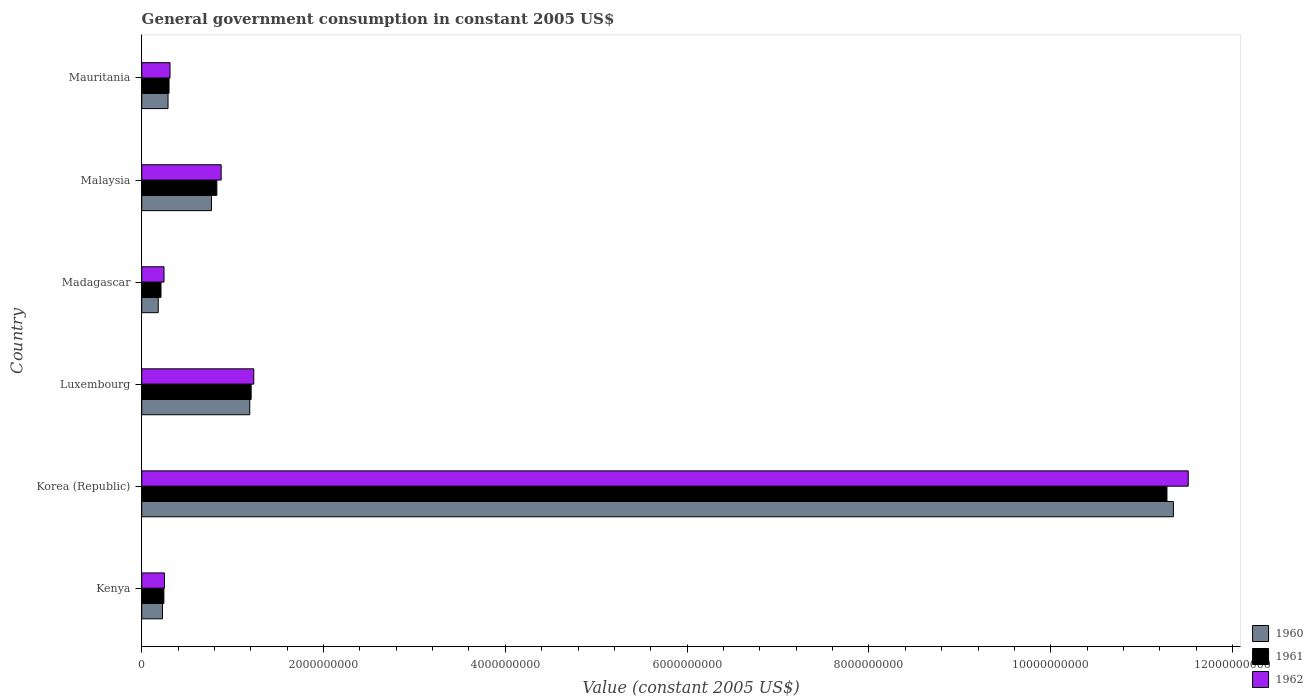In how many cases, is the number of bars for a given country not equal to the number of legend labels?
Give a very brief answer. 0. What is the government conusmption in 1961 in Korea (Republic)?
Your answer should be compact. 1.13e+1. Across all countries, what is the maximum government conusmption in 1961?
Your answer should be very brief. 1.13e+1. Across all countries, what is the minimum government conusmption in 1962?
Your answer should be very brief. 2.45e+08. In which country was the government conusmption in 1960 maximum?
Provide a succinct answer. Korea (Republic). In which country was the government conusmption in 1961 minimum?
Provide a short and direct response. Madagascar. What is the total government conusmption in 1960 in the graph?
Your response must be concise. 1.40e+1. What is the difference between the government conusmption in 1960 in Korea (Republic) and that in Mauritania?
Your response must be concise. 1.11e+1. What is the difference between the government conusmption in 1962 in Luxembourg and the government conusmption in 1960 in Kenya?
Offer a very short reply. 1.00e+09. What is the average government conusmption in 1961 per country?
Your answer should be compact. 2.34e+09. What is the difference between the government conusmption in 1962 and government conusmption in 1961 in Korea (Republic)?
Keep it short and to the point. 2.34e+08. What is the ratio of the government conusmption in 1960 in Madagascar to that in Malaysia?
Provide a succinct answer. 0.24. Is the government conusmption in 1962 in Kenya less than that in Luxembourg?
Your answer should be compact. Yes. Is the difference between the government conusmption in 1962 in Luxembourg and Madagascar greater than the difference between the government conusmption in 1961 in Luxembourg and Madagascar?
Offer a terse response. No. What is the difference between the highest and the second highest government conusmption in 1960?
Your answer should be compact. 1.02e+1. What is the difference between the highest and the lowest government conusmption in 1962?
Your answer should be very brief. 1.13e+1. What does the 1st bar from the bottom in Madagascar represents?
Keep it short and to the point. 1960. Is it the case that in every country, the sum of the government conusmption in 1962 and government conusmption in 1960 is greater than the government conusmption in 1961?
Give a very brief answer. Yes. Are all the bars in the graph horizontal?
Your response must be concise. Yes. How many countries are there in the graph?
Your answer should be compact. 6. Are the values on the major ticks of X-axis written in scientific E-notation?
Provide a short and direct response. No. Does the graph contain any zero values?
Make the answer very short. No. Does the graph contain grids?
Your response must be concise. No. Where does the legend appear in the graph?
Provide a succinct answer. Bottom right. How many legend labels are there?
Offer a terse response. 3. How are the legend labels stacked?
Make the answer very short. Vertical. What is the title of the graph?
Your response must be concise. General government consumption in constant 2005 US$. Does "2004" appear as one of the legend labels in the graph?
Offer a very short reply. No. What is the label or title of the X-axis?
Your answer should be very brief. Value (constant 2005 US$). What is the Value (constant 2005 US$) of 1960 in Kenya?
Your answer should be very brief. 2.28e+08. What is the Value (constant 2005 US$) in 1961 in Kenya?
Provide a short and direct response. 2.44e+08. What is the Value (constant 2005 US$) in 1962 in Kenya?
Keep it short and to the point. 2.50e+08. What is the Value (constant 2005 US$) in 1960 in Korea (Republic)?
Your answer should be compact. 1.13e+1. What is the Value (constant 2005 US$) of 1961 in Korea (Republic)?
Make the answer very short. 1.13e+1. What is the Value (constant 2005 US$) of 1962 in Korea (Republic)?
Give a very brief answer. 1.15e+1. What is the Value (constant 2005 US$) in 1960 in Luxembourg?
Your answer should be very brief. 1.19e+09. What is the Value (constant 2005 US$) of 1961 in Luxembourg?
Give a very brief answer. 1.20e+09. What is the Value (constant 2005 US$) of 1962 in Luxembourg?
Give a very brief answer. 1.23e+09. What is the Value (constant 2005 US$) in 1960 in Madagascar?
Provide a succinct answer. 1.82e+08. What is the Value (constant 2005 US$) in 1961 in Madagascar?
Provide a short and direct response. 2.12e+08. What is the Value (constant 2005 US$) in 1962 in Madagascar?
Your response must be concise. 2.45e+08. What is the Value (constant 2005 US$) of 1960 in Malaysia?
Offer a terse response. 7.67e+08. What is the Value (constant 2005 US$) in 1961 in Malaysia?
Ensure brevity in your answer.  8.26e+08. What is the Value (constant 2005 US$) in 1962 in Malaysia?
Offer a terse response. 8.74e+08. What is the Value (constant 2005 US$) in 1960 in Mauritania?
Your answer should be compact. 2.89e+08. What is the Value (constant 2005 US$) in 1961 in Mauritania?
Ensure brevity in your answer.  3.00e+08. What is the Value (constant 2005 US$) in 1962 in Mauritania?
Provide a short and direct response. 3.11e+08. Across all countries, what is the maximum Value (constant 2005 US$) of 1960?
Give a very brief answer. 1.13e+1. Across all countries, what is the maximum Value (constant 2005 US$) in 1961?
Ensure brevity in your answer.  1.13e+1. Across all countries, what is the maximum Value (constant 2005 US$) in 1962?
Ensure brevity in your answer.  1.15e+1. Across all countries, what is the minimum Value (constant 2005 US$) of 1960?
Your answer should be very brief. 1.82e+08. Across all countries, what is the minimum Value (constant 2005 US$) of 1961?
Ensure brevity in your answer.  2.12e+08. Across all countries, what is the minimum Value (constant 2005 US$) of 1962?
Your answer should be compact. 2.45e+08. What is the total Value (constant 2005 US$) of 1960 in the graph?
Your response must be concise. 1.40e+1. What is the total Value (constant 2005 US$) in 1961 in the graph?
Ensure brevity in your answer.  1.41e+1. What is the total Value (constant 2005 US$) of 1962 in the graph?
Offer a terse response. 1.44e+1. What is the difference between the Value (constant 2005 US$) of 1960 in Kenya and that in Korea (Republic)?
Your response must be concise. -1.11e+1. What is the difference between the Value (constant 2005 US$) of 1961 in Kenya and that in Korea (Republic)?
Keep it short and to the point. -1.10e+1. What is the difference between the Value (constant 2005 US$) of 1962 in Kenya and that in Korea (Republic)?
Your answer should be compact. -1.13e+1. What is the difference between the Value (constant 2005 US$) of 1960 in Kenya and that in Luxembourg?
Offer a terse response. -9.60e+08. What is the difference between the Value (constant 2005 US$) of 1961 in Kenya and that in Luxembourg?
Offer a very short reply. -9.60e+08. What is the difference between the Value (constant 2005 US$) in 1962 in Kenya and that in Luxembourg?
Offer a very short reply. -9.82e+08. What is the difference between the Value (constant 2005 US$) in 1960 in Kenya and that in Madagascar?
Provide a succinct answer. 4.65e+07. What is the difference between the Value (constant 2005 US$) in 1961 in Kenya and that in Madagascar?
Offer a very short reply. 3.18e+07. What is the difference between the Value (constant 2005 US$) in 1962 in Kenya and that in Madagascar?
Provide a short and direct response. 5.27e+06. What is the difference between the Value (constant 2005 US$) in 1960 in Kenya and that in Malaysia?
Your response must be concise. -5.39e+08. What is the difference between the Value (constant 2005 US$) of 1961 in Kenya and that in Malaysia?
Your answer should be compact. -5.83e+08. What is the difference between the Value (constant 2005 US$) in 1962 in Kenya and that in Malaysia?
Your response must be concise. -6.24e+08. What is the difference between the Value (constant 2005 US$) in 1960 in Kenya and that in Mauritania?
Offer a very short reply. -6.12e+07. What is the difference between the Value (constant 2005 US$) in 1961 in Kenya and that in Mauritania?
Keep it short and to the point. -5.66e+07. What is the difference between the Value (constant 2005 US$) of 1962 in Kenya and that in Mauritania?
Your answer should be compact. -6.09e+07. What is the difference between the Value (constant 2005 US$) of 1960 in Korea (Republic) and that in Luxembourg?
Offer a terse response. 1.02e+1. What is the difference between the Value (constant 2005 US$) in 1961 in Korea (Republic) and that in Luxembourg?
Give a very brief answer. 1.01e+1. What is the difference between the Value (constant 2005 US$) of 1962 in Korea (Republic) and that in Luxembourg?
Provide a succinct answer. 1.03e+1. What is the difference between the Value (constant 2005 US$) in 1960 in Korea (Republic) and that in Madagascar?
Provide a succinct answer. 1.12e+1. What is the difference between the Value (constant 2005 US$) in 1961 in Korea (Republic) and that in Madagascar?
Your response must be concise. 1.11e+1. What is the difference between the Value (constant 2005 US$) of 1962 in Korea (Republic) and that in Madagascar?
Provide a short and direct response. 1.13e+1. What is the difference between the Value (constant 2005 US$) of 1960 in Korea (Republic) and that in Malaysia?
Ensure brevity in your answer.  1.06e+1. What is the difference between the Value (constant 2005 US$) of 1961 in Korea (Republic) and that in Malaysia?
Give a very brief answer. 1.05e+1. What is the difference between the Value (constant 2005 US$) of 1962 in Korea (Republic) and that in Malaysia?
Offer a terse response. 1.06e+1. What is the difference between the Value (constant 2005 US$) in 1960 in Korea (Republic) and that in Mauritania?
Keep it short and to the point. 1.11e+1. What is the difference between the Value (constant 2005 US$) in 1961 in Korea (Republic) and that in Mauritania?
Ensure brevity in your answer.  1.10e+1. What is the difference between the Value (constant 2005 US$) in 1962 in Korea (Republic) and that in Mauritania?
Your answer should be very brief. 1.12e+1. What is the difference between the Value (constant 2005 US$) in 1960 in Luxembourg and that in Madagascar?
Keep it short and to the point. 1.01e+09. What is the difference between the Value (constant 2005 US$) of 1961 in Luxembourg and that in Madagascar?
Ensure brevity in your answer.  9.92e+08. What is the difference between the Value (constant 2005 US$) in 1962 in Luxembourg and that in Madagascar?
Ensure brevity in your answer.  9.87e+08. What is the difference between the Value (constant 2005 US$) in 1960 in Luxembourg and that in Malaysia?
Your response must be concise. 4.21e+08. What is the difference between the Value (constant 2005 US$) in 1961 in Luxembourg and that in Malaysia?
Offer a terse response. 3.77e+08. What is the difference between the Value (constant 2005 US$) of 1962 in Luxembourg and that in Malaysia?
Your answer should be very brief. 3.59e+08. What is the difference between the Value (constant 2005 US$) of 1960 in Luxembourg and that in Mauritania?
Offer a terse response. 8.99e+08. What is the difference between the Value (constant 2005 US$) of 1961 in Luxembourg and that in Mauritania?
Provide a short and direct response. 9.03e+08. What is the difference between the Value (constant 2005 US$) in 1962 in Luxembourg and that in Mauritania?
Make the answer very short. 9.21e+08. What is the difference between the Value (constant 2005 US$) of 1960 in Madagascar and that in Malaysia?
Your response must be concise. -5.85e+08. What is the difference between the Value (constant 2005 US$) of 1961 in Madagascar and that in Malaysia?
Provide a succinct answer. -6.14e+08. What is the difference between the Value (constant 2005 US$) in 1962 in Madagascar and that in Malaysia?
Provide a succinct answer. -6.29e+08. What is the difference between the Value (constant 2005 US$) in 1960 in Madagascar and that in Mauritania?
Give a very brief answer. -1.08e+08. What is the difference between the Value (constant 2005 US$) in 1961 in Madagascar and that in Mauritania?
Your answer should be very brief. -8.84e+07. What is the difference between the Value (constant 2005 US$) in 1962 in Madagascar and that in Mauritania?
Offer a very short reply. -6.62e+07. What is the difference between the Value (constant 2005 US$) of 1960 in Malaysia and that in Mauritania?
Keep it short and to the point. 4.78e+08. What is the difference between the Value (constant 2005 US$) of 1961 in Malaysia and that in Mauritania?
Provide a short and direct response. 5.26e+08. What is the difference between the Value (constant 2005 US$) in 1962 in Malaysia and that in Mauritania?
Provide a short and direct response. 5.63e+08. What is the difference between the Value (constant 2005 US$) in 1960 in Kenya and the Value (constant 2005 US$) in 1961 in Korea (Republic)?
Provide a succinct answer. -1.11e+1. What is the difference between the Value (constant 2005 US$) in 1960 in Kenya and the Value (constant 2005 US$) in 1962 in Korea (Republic)?
Provide a short and direct response. -1.13e+1. What is the difference between the Value (constant 2005 US$) in 1961 in Kenya and the Value (constant 2005 US$) in 1962 in Korea (Republic)?
Your answer should be compact. -1.13e+1. What is the difference between the Value (constant 2005 US$) in 1960 in Kenya and the Value (constant 2005 US$) in 1961 in Luxembourg?
Offer a terse response. -9.75e+08. What is the difference between the Value (constant 2005 US$) of 1960 in Kenya and the Value (constant 2005 US$) of 1962 in Luxembourg?
Provide a short and direct response. -1.00e+09. What is the difference between the Value (constant 2005 US$) in 1961 in Kenya and the Value (constant 2005 US$) in 1962 in Luxembourg?
Provide a succinct answer. -9.89e+08. What is the difference between the Value (constant 2005 US$) of 1960 in Kenya and the Value (constant 2005 US$) of 1961 in Madagascar?
Your response must be concise. 1.63e+07. What is the difference between the Value (constant 2005 US$) in 1960 in Kenya and the Value (constant 2005 US$) in 1962 in Madagascar?
Ensure brevity in your answer.  -1.69e+07. What is the difference between the Value (constant 2005 US$) in 1961 in Kenya and the Value (constant 2005 US$) in 1962 in Madagascar?
Make the answer very short. -1.39e+06. What is the difference between the Value (constant 2005 US$) in 1960 in Kenya and the Value (constant 2005 US$) in 1961 in Malaysia?
Your answer should be compact. -5.98e+08. What is the difference between the Value (constant 2005 US$) of 1960 in Kenya and the Value (constant 2005 US$) of 1962 in Malaysia?
Your response must be concise. -6.46e+08. What is the difference between the Value (constant 2005 US$) of 1961 in Kenya and the Value (constant 2005 US$) of 1962 in Malaysia?
Make the answer very short. -6.30e+08. What is the difference between the Value (constant 2005 US$) of 1960 in Kenya and the Value (constant 2005 US$) of 1961 in Mauritania?
Your response must be concise. -7.21e+07. What is the difference between the Value (constant 2005 US$) in 1960 in Kenya and the Value (constant 2005 US$) in 1962 in Mauritania?
Ensure brevity in your answer.  -8.31e+07. What is the difference between the Value (constant 2005 US$) of 1961 in Kenya and the Value (constant 2005 US$) of 1962 in Mauritania?
Make the answer very short. -6.76e+07. What is the difference between the Value (constant 2005 US$) in 1960 in Korea (Republic) and the Value (constant 2005 US$) in 1961 in Luxembourg?
Your response must be concise. 1.01e+1. What is the difference between the Value (constant 2005 US$) of 1960 in Korea (Republic) and the Value (constant 2005 US$) of 1962 in Luxembourg?
Offer a very short reply. 1.01e+1. What is the difference between the Value (constant 2005 US$) in 1961 in Korea (Republic) and the Value (constant 2005 US$) in 1962 in Luxembourg?
Provide a short and direct response. 1.00e+1. What is the difference between the Value (constant 2005 US$) of 1960 in Korea (Republic) and the Value (constant 2005 US$) of 1961 in Madagascar?
Make the answer very short. 1.11e+1. What is the difference between the Value (constant 2005 US$) in 1960 in Korea (Republic) and the Value (constant 2005 US$) in 1962 in Madagascar?
Ensure brevity in your answer.  1.11e+1. What is the difference between the Value (constant 2005 US$) of 1961 in Korea (Republic) and the Value (constant 2005 US$) of 1962 in Madagascar?
Make the answer very short. 1.10e+1. What is the difference between the Value (constant 2005 US$) in 1960 in Korea (Republic) and the Value (constant 2005 US$) in 1961 in Malaysia?
Provide a succinct answer. 1.05e+1. What is the difference between the Value (constant 2005 US$) of 1960 in Korea (Republic) and the Value (constant 2005 US$) of 1962 in Malaysia?
Keep it short and to the point. 1.05e+1. What is the difference between the Value (constant 2005 US$) of 1961 in Korea (Republic) and the Value (constant 2005 US$) of 1962 in Malaysia?
Provide a succinct answer. 1.04e+1. What is the difference between the Value (constant 2005 US$) in 1960 in Korea (Republic) and the Value (constant 2005 US$) in 1961 in Mauritania?
Provide a short and direct response. 1.10e+1. What is the difference between the Value (constant 2005 US$) in 1960 in Korea (Republic) and the Value (constant 2005 US$) in 1962 in Mauritania?
Give a very brief answer. 1.10e+1. What is the difference between the Value (constant 2005 US$) of 1961 in Korea (Republic) and the Value (constant 2005 US$) of 1962 in Mauritania?
Your response must be concise. 1.10e+1. What is the difference between the Value (constant 2005 US$) of 1960 in Luxembourg and the Value (constant 2005 US$) of 1961 in Madagascar?
Make the answer very short. 9.76e+08. What is the difference between the Value (constant 2005 US$) in 1960 in Luxembourg and the Value (constant 2005 US$) in 1962 in Madagascar?
Offer a very short reply. 9.43e+08. What is the difference between the Value (constant 2005 US$) in 1961 in Luxembourg and the Value (constant 2005 US$) in 1962 in Madagascar?
Your response must be concise. 9.59e+08. What is the difference between the Value (constant 2005 US$) of 1960 in Luxembourg and the Value (constant 2005 US$) of 1961 in Malaysia?
Offer a very short reply. 3.62e+08. What is the difference between the Value (constant 2005 US$) of 1960 in Luxembourg and the Value (constant 2005 US$) of 1962 in Malaysia?
Give a very brief answer. 3.14e+08. What is the difference between the Value (constant 2005 US$) of 1961 in Luxembourg and the Value (constant 2005 US$) of 1962 in Malaysia?
Ensure brevity in your answer.  3.30e+08. What is the difference between the Value (constant 2005 US$) of 1960 in Luxembourg and the Value (constant 2005 US$) of 1961 in Mauritania?
Make the answer very short. 8.88e+08. What is the difference between the Value (constant 2005 US$) of 1960 in Luxembourg and the Value (constant 2005 US$) of 1962 in Mauritania?
Your answer should be very brief. 8.77e+08. What is the difference between the Value (constant 2005 US$) in 1961 in Luxembourg and the Value (constant 2005 US$) in 1962 in Mauritania?
Provide a succinct answer. 8.92e+08. What is the difference between the Value (constant 2005 US$) in 1960 in Madagascar and the Value (constant 2005 US$) in 1961 in Malaysia?
Ensure brevity in your answer.  -6.45e+08. What is the difference between the Value (constant 2005 US$) in 1960 in Madagascar and the Value (constant 2005 US$) in 1962 in Malaysia?
Provide a succinct answer. -6.92e+08. What is the difference between the Value (constant 2005 US$) in 1961 in Madagascar and the Value (constant 2005 US$) in 1962 in Malaysia?
Your response must be concise. -6.62e+08. What is the difference between the Value (constant 2005 US$) in 1960 in Madagascar and the Value (constant 2005 US$) in 1961 in Mauritania?
Your answer should be very brief. -1.19e+08. What is the difference between the Value (constant 2005 US$) in 1960 in Madagascar and the Value (constant 2005 US$) in 1962 in Mauritania?
Provide a succinct answer. -1.30e+08. What is the difference between the Value (constant 2005 US$) of 1961 in Madagascar and the Value (constant 2005 US$) of 1962 in Mauritania?
Your answer should be very brief. -9.93e+07. What is the difference between the Value (constant 2005 US$) in 1960 in Malaysia and the Value (constant 2005 US$) in 1961 in Mauritania?
Make the answer very short. 4.67e+08. What is the difference between the Value (constant 2005 US$) in 1960 in Malaysia and the Value (constant 2005 US$) in 1962 in Mauritania?
Make the answer very short. 4.56e+08. What is the difference between the Value (constant 2005 US$) of 1961 in Malaysia and the Value (constant 2005 US$) of 1962 in Mauritania?
Give a very brief answer. 5.15e+08. What is the average Value (constant 2005 US$) in 1960 per country?
Offer a very short reply. 2.33e+09. What is the average Value (constant 2005 US$) of 1961 per country?
Provide a succinct answer. 2.34e+09. What is the average Value (constant 2005 US$) of 1962 per country?
Offer a very short reply. 2.40e+09. What is the difference between the Value (constant 2005 US$) of 1960 and Value (constant 2005 US$) of 1961 in Kenya?
Make the answer very short. -1.55e+07. What is the difference between the Value (constant 2005 US$) in 1960 and Value (constant 2005 US$) in 1962 in Kenya?
Offer a very short reply. -2.21e+07. What is the difference between the Value (constant 2005 US$) in 1961 and Value (constant 2005 US$) in 1962 in Kenya?
Offer a terse response. -6.66e+06. What is the difference between the Value (constant 2005 US$) of 1960 and Value (constant 2005 US$) of 1961 in Korea (Republic)?
Ensure brevity in your answer.  7.08e+07. What is the difference between the Value (constant 2005 US$) of 1960 and Value (constant 2005 US$) of 1962 in Korea (Republic)?
Make the answer very short. -1.63e+08. What is the difference between the Value (constant 2005 US$) of 1961 and Value (constant 2005 US$) of 1962 in Korea (Republic)?
Your answer should be compact. -2.34e+08. What is the difference between the Value (constant 2005 US$) in 1960 and Value (constant 2005 US$) in 1961 in Luxembourg?
Make the answer very short. -1.55e+07. What is the difference between the Value (constant 2005 US$) of 1960 and Value (constant 2005 US$) of 1962 in Luxembourg?
Offer a very short reply. -4.43e+07. What is the difference between the Value (constant 2005 US$) in 1961 and Value (constant 2005 US$) in 1962 in Luxembourg?
Ensure brevity in your answer.  -2.88e+07. What is the difference between the Value (constant 2005 US$) in 1960 and Value (constant 2005 US$) in 1961 in Madagascar?
Ensure brevity in your answer.  -3.02e+07. What is the difference between the Value (constant 2005 US$) of 1960 and Value (constant 2005 US$) of 1962 in Madagascar?
Ensure brevity in your answer.  -6.34e+07. What is the difference between the Value (constant 2005 US$) in 1961 and Value (constant 2005 US$) in 1962 in Madagascar?
Make the answer very short. -3.32e+07. What is the difference between the Value (constant 2005 US$) in 1960 and Value (constant 2005 US$) in 1961 in Malaysia?
Offer a very short reply. -5.92e+07. What is the difference between the Value (constant 2005 US$) of 1960 and Value (constant 2005 US$) of 1962 in Malaysia?
Provide a succinct answer. -1.07e+08. What is the difference between the Value (constant 2005 US$) of 1961 and Value (constant 2005 US$) of 1962 in Malaysia?
Make the answer very short. -4.75e+07. What is the difference between the Value (constant 2005 US$) in 1960 and Value (constant 2005 US$) in 1961 in Mauritania?
Your answer should be compact. -1.09e+07. What is the difference between the Value (constant 2005 US$) in 1960 and Value (constant 2005 US$) in 1962 in Mauritania?
Make the answer very short. -2.18e+07. What is the difference between the Value (constant 2005 US$) in 1961 and Value (constant 2005 US$) in 1962 in Mauritania?
Provide a short and direct response. -1.09e+07. What is the ratio of the Value (constant 2005 US$) in 1960 in Kenya to that in Korea (Republic)?
Offer a terse response. 0.02. What is the ratio of the Value (constant 2005 US$) in 1961 in Kenya to that in Korea (Republic)?
Ensure brevity in your answer.  0.02. What is the ratio of the Value (constant 2005 US$) of 1962 in Kenya to that in Korea (Republic)?
Provide a short and direct response. 0.02. What is the ratio of the Value (constant 2005 US$) of 1960 in Kenya to that in Luxembourg?
Your answer should be very brief. 0.19. What is the ratio of the Value (constant 2005 US$) of 1961 in Kenya to that in Luxembourg?
Your answer should be very brief. 0.2. What is the ratio of the Value (constant 2005 US$) in 1962 in Kenya to that in Luxembourg?
Offer a terse response. 0.2. What is the ratio of the Value (constant 2005 US$) in 1960 in Kenya to that in Madagascar?
Provide a short and direct response. 1.26. What is the ratio of the Value (constant 2005 US$) in 1961 in Kenya to that in Madagascar?
Provide a short and direct response. 1.15. What is the ratio of the Value (constant 2005 US$) of 1962 in Kenya to that in Madagascar?
Make the answer very short. 1.02. What is the ratio of the Value (constant 2005 US$) of 1960 in Kenya to that in Malaysia?
Keep it short and to the point. 0.3. What is the ratio of the Value (constant 2005 US$) of 1961 in Kenya to that in Malaysia?
Keep it short and to the point. 0.29. What is the ratio of the Value (constant 2005 US$) of 1962 in Kenya to that in Malaysia?
Give a very brief answer. 0.29. What is the ratio of the Value (constant 2005 US$) in 1960 in Kenya to that in Mauritania?
Keep it short and to the point. 0.79. What is the ratio of the Value (constant 2005 US$) in 1961 in Kenya to that in Mauritania?
Your answer should be very brief. 0.81. What is the ratio of the Value (constant 2005 US$) of 1962 in Kenya to that in Mauritania?
Provide a succinct answer. 0.8. What is the ratio of the Value (constant 2005 US$) in 1960 in Korea (Republic) to that in Luxembourg?
Keep it short and to the point. 9.55. What is the ratio of the Value (constant 2005 US$) in 1961 in Korea (Republic) to that in Luxembourg?
Provide a succinct answer. 9.37. What is the ratio of the Value (constant 2005 US$) in 1962 in Korea (Republic) to that in Luxembourg?
Offer a very short reply. 9.34. What is the ratio of the Value (constant 2005 US$) of 1960 in Korea (Republic) to that in Madagascar?
Give a very brief answer. 62.43. What is the ratio of the Value (constant 2005 US$) in 1961 in Korea (Republic) to that in Madagascar?
Your response must be concise. 53.2. What is the ratio of the Value (constant 2005 US$) of 1962 in Korea (Republic) to that in Madagascar?
Your response must be concise. 46.96. What is the ratio of the Value (constant 2005 US$) of 1960 in Korea (Republic) to that in Malaysia?
Give a very brief answer. 14.79. What is the ratio of the Value (constant 2005 US$) in 1961 in Korea (Republic) to that in Malaysia?
Your answer should be very brief. 13.65. What is the ratio of the Value (constant 2005 US$) in 1962 in Korea (Republic) to that in Malaysia?
Your answer should be very brief. 13.17. What is the ratio of the Value (constant 2005 US$) in 1960 in Korea (Republic) to that in Mauritania?
Offer a very short reply. 39.21. What is the ratio of the Value (constant 2005 US$) in 1961 in Korea (Republic) to that in Mauritania?
Your response must be concise. 37.55. What is the ratio of the Value (constant 2005 US$) of 1962 in Korea (Republic) to that in Mauritania?
Provide a short and direct response. 36.98. What is the ratio of the Value (constant 2005 US$) in 1960 in Luxembourg to that in Madagascar?
Give a very brief answer. 6.54. What is the ratio of the Value (constant 2005 US$) of 1961 in Luxembourg to that in Madagascar?
Provide a short and direct response. 5.68. What is the ratio of the Value (constant 2005 US$) in 1962 in Luxembourg to that in Madagascar?
Keep it short and to the point. 5.03. What is the ratio of the Value (constant 2005 US$) in 1960 in Luxembourg to that in Malaysia?
Make the answer very short. 1.55. What is the ratio of the Value (constant 2005 US$) of 1961 in Luxembourg to that in Malaysia?
Offer a very short reply. 1.46. What is the ratio of the Value (constant 2005 US$) in 1962 in Luxembourg to that in Malaysia?
Your answer should be compact. 1.41. What is the ratio of the Value (constant 2005 US$) of 1960 in Luxembourg to that in Mauritania?
Offer a terse response. 4.11. What is the ratio of the Value (constant 2005 US$) in 1961 in Luxembourg to that in Mauritania?
Provide a short and direct response. 4.01. What is the ratio of the Value (constant 2005 US$) of 1962 in Luxembourg to that in Mauritania?
Provide a succinct answer. 3.96. What is the ratio of the Value (constant 2005 US$) of 1960 in Madagascar to that in Malaysia?
Your response must be concise. 0.24. What is the ratio of the Value (constant 2005 US$) of 1961 in Madagascar to that in Malaysia?
Provide a succinct answer. 0.26. What is the ratio of the Value (constant 2005 US$) of 1962 in Madagascar to that in Malaysia?
Provide a succinct answer. 0.28. What is the ratio of the Value (constant 2005 US$) of 1960 in Madagascar to that in Mauritania?
Provide a short and direct response. 0.63. What is the ratio of the Value (constant 2005 US$) in 1961 in Madagascar to that in Mauritania?
Offer a terse response. 0.71. What is the ratio of the Value (constant 2005 US$) of 1962 in Madagascar to that in Mauritania?
Ensure brevity in your answer.  0.79. What is the ratio of the Value (constant 2005 US$) in 1960 in Malaysia to that in Mauritania?
Keep it short and to the point. 2.65. What is the ratio of the Value (constant 2005 US$) of 1961 in Malaysia to that in Mauritania?
Keep it short and to the point. 2.75. What is the ratio of the Value (constant 2005 US$) in 1962 in Malaysia to that in Mauritania?
Make the answer very short. 2.81. What is the difference between the highest and the second highest Value (constant 2005 US$) of 1960?
Make the answer very short. 1.02e+1. What is the difference between the highest and the second highest Value (constant 2005 US$) in 1961?
Your answer should be very brief. 1.01e+1. What is the difference between the highest and the second highest Value (constant 2005 US$) of 1962?
Your answer should be compact. 1.03e+1. What is the difference between the highest and the lowest Value (constant 2005 US$) in 1960?
Offer a terse response. 1.12e+1. What is the difference between the highest and the lowest Value (constant 2005 US$) in 1961?
Ensure brevity in your answer.  1.11e+1. What is the difference between the highest and the lowest Value (constant 2005 US$) of 1962?
Provide a short and direct response. 1.13e+1. 